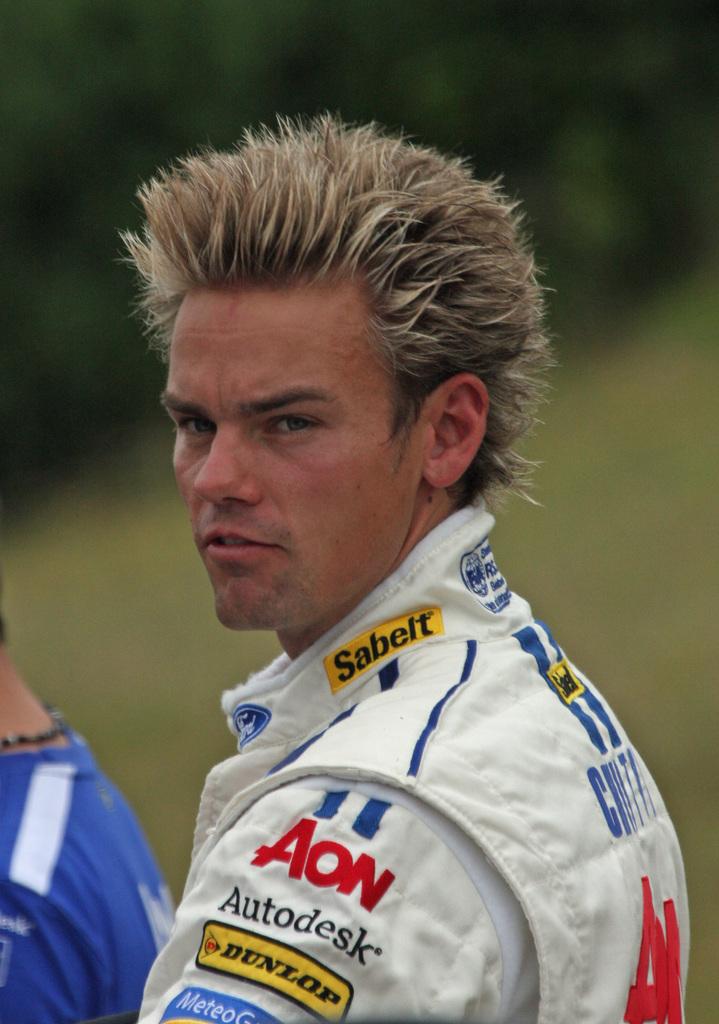What type of tires are advertised on his arm?
Provide a short and direct response. Dunlop. What company name is the red logo?
Your answer should be compact. Aon. 